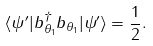Convert formula to latex. <formula><loc_0><loc_0><loc_500><loc_500>\langle \psi ^ { \prime } | b ^ { \dag } _ { \theta _ { 1 } } b _ { \theta _ { 1 } } | \psi ^ { \prime } \rangle = \frac { 1 } { 2 } .</formula> 